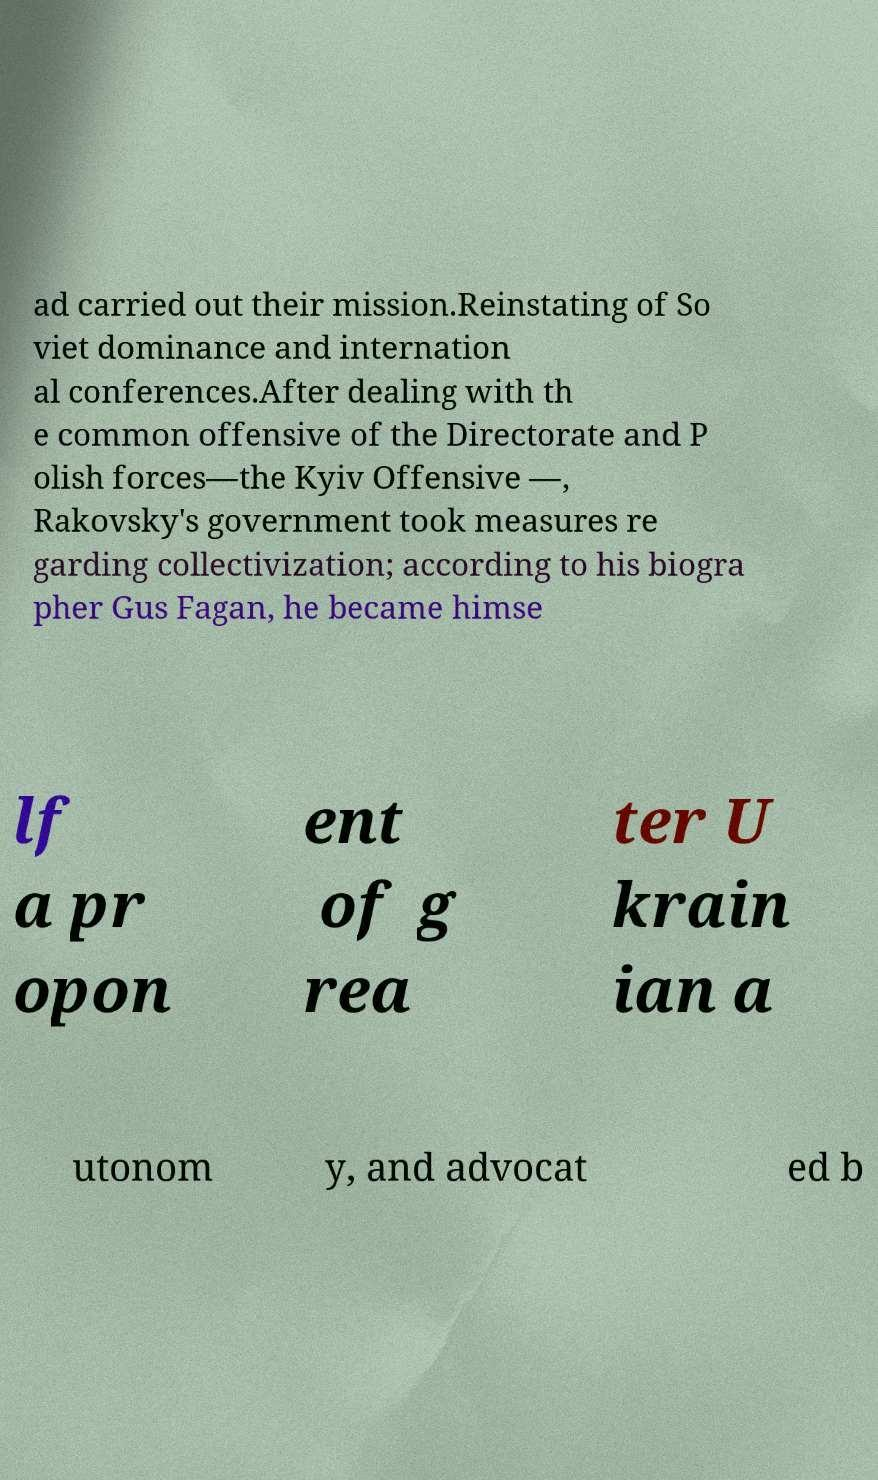Can you read and provide the text displayed in the image?This photo seems to have some interesting text. Can you extract and type it out for me? ad carried out their mission.Reinstating of So viet dominance and internation al conferences.After dealing with th e common offensive of the Directorate and P olish forces—the Kyiv Offensive —, Rakovsky's government took measures re garding collectivization; according to his biogra pher Gus Fagan, he became himse lf a pr opon ent of g rea ter U krain ian a utonom y, and advocat ed b 